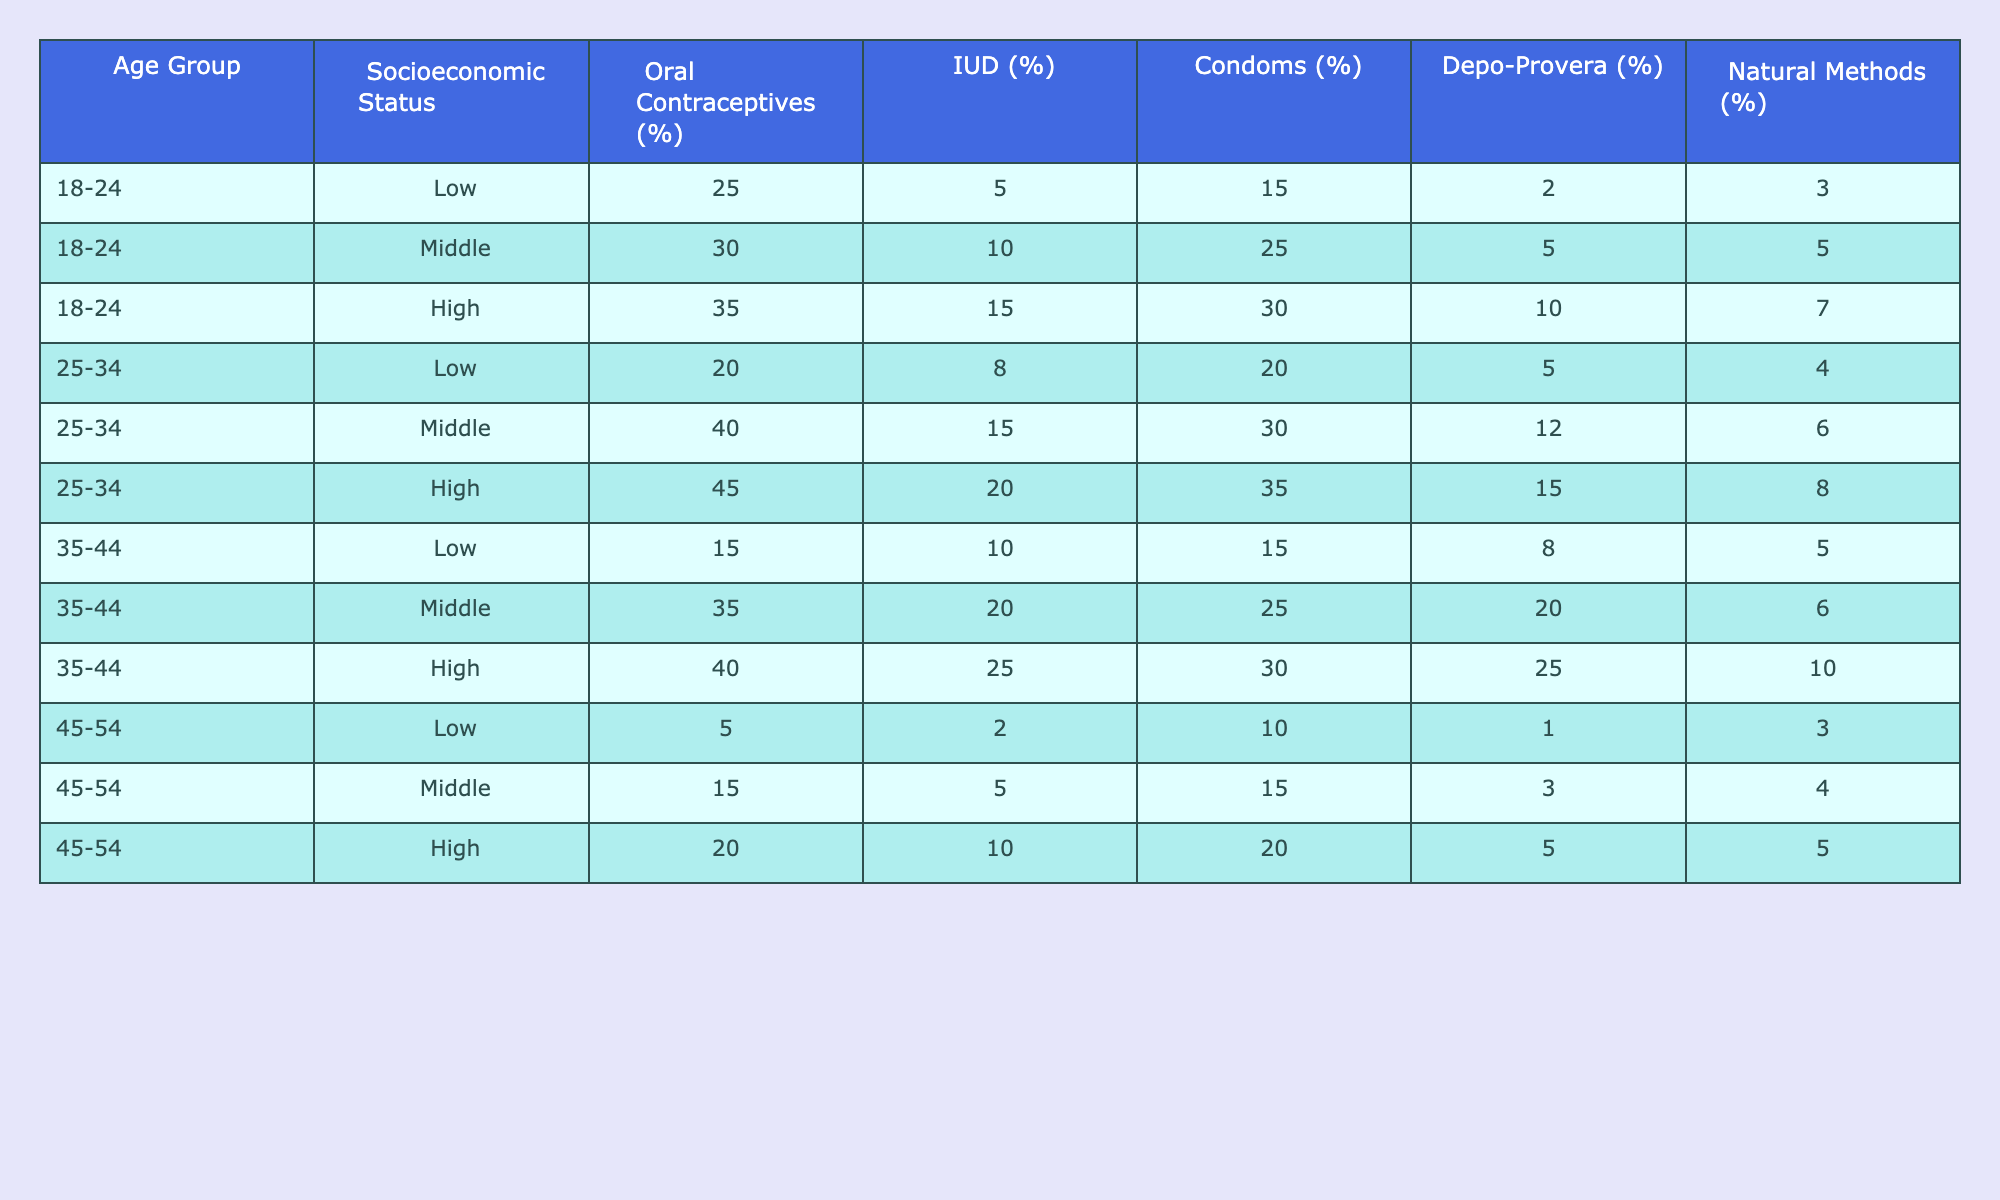What percentage of women aged 18-24 with a low socioeconomic status use Depo-Provera? From the table, for the age group 18-24 and low socioeconomic status, the percentage using Depo-Provera is given directly in the table. It shows as 2%.
Answer: 2% What is the most common contraceptive method among women aged 25-34 with a middle socioeconomic status? The table lists the percentages for each contraceptive method for the 25-34 age group in the middle socioeconomic status row. The highest percentage is for oral contraceptives, which is 40%.
Answer: Oral contraceptives What are the total percentages of IUD use across all age groups for women with high socioeconomic status? We need to sum the IUD percentages for each age group with a high socioeconomic status: 15% (18-24) + 20% (25-34) + 25% (35-44) + 10% (45-54) = 70%.
Answer: 70% Is it true that the usage of natural methods increases with age for women in a low socioeconomic status? We can observe the percentages for natural methods in the low socioeconomic status row for each age group: 3% (18-24), 4% (25-34), 5% (35-44), and 3% (45-54). The values do not show a clear increase with age. Hence, the statement is false.
Answer: No What is the average percentage of condom usage among women aged 35-44 across all socioeconomic statuses? The percentages for condom usage for age 35-44 in each socioeconomic status are 15% (low), 25% (middle), and 30% (high). To calculate the average, we sum these percentages: 15 + 25 + 30 = 70, then divide by 3 (the number of statuses) yielding an average of 70/3 = 23.33%.
Answer: 23.33% How does the use of oral contraceptives compare for women aged 45-54 in low versus high socioeconomic status? For women aged 45-54, low socioeconomic status shows oral contraceptive usage at 5%, while high socioeconomic status shows it at 20%. This indicates that women in high socioeconomic status use oral contraceptives 15% more than their low-status counterparts.
Answer: 15% difference What percentage of women in the 18-24 age group use condoms if they are in middle socioeconomic status? Directly referring to the table for women aged 18-24 and middle socioeconomic status, the percentage reported for condom usage is 25%.
Answer: 25% Do women in the high socioeconomic status group exhibit higher usage of Depo-Provera than those in the low socioeconomic status group for the 35-44 age range? For women aged 35-44, the table shows Depo-Provera usage at 25% for high socioeconomic status and 8% for low socioeconomic status. Since 25% is higher than 8%, the statement is true.
Answer: Yes 